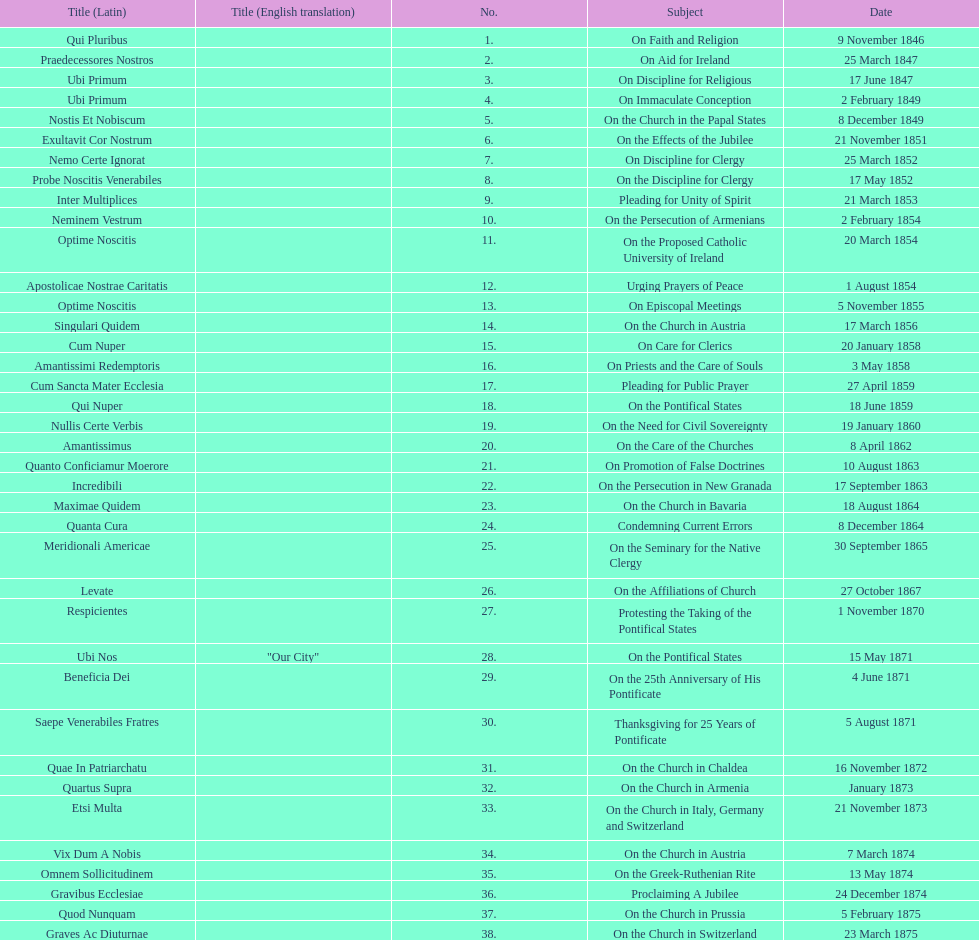Total number of encyclicals on churches . 11. 